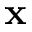Convert formula to latex. <formula><loc_0><loc_0><loc_500><loc_500>x</formula> 